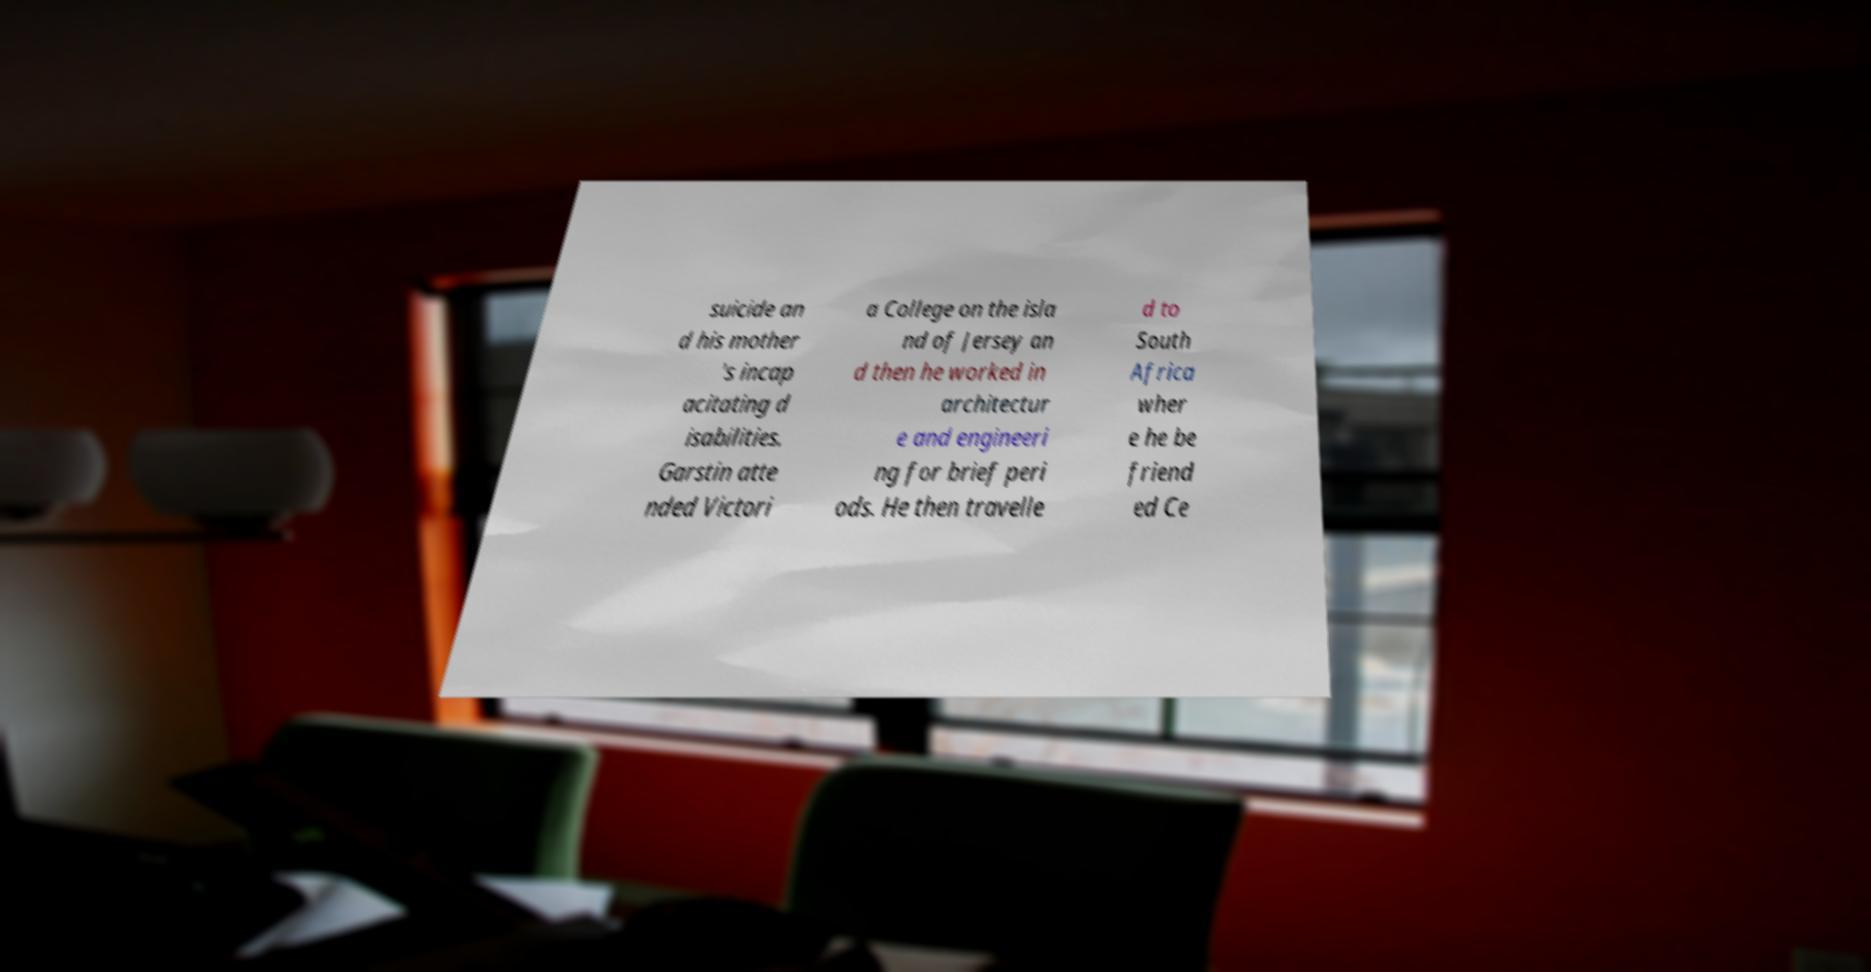Can you read and provide the text displayed in the image?This photo seems to have some interesting text. Can you extract and type it out for me? suicide an d his mother 's incap acitating d isabilities. Garstin atte nded Victori a College on the isla nd of Jersey an d then he worked in architectur e and engineeri ng for brief peri ods. He then travelle d to South Africa wher e he be friend ed Ce 